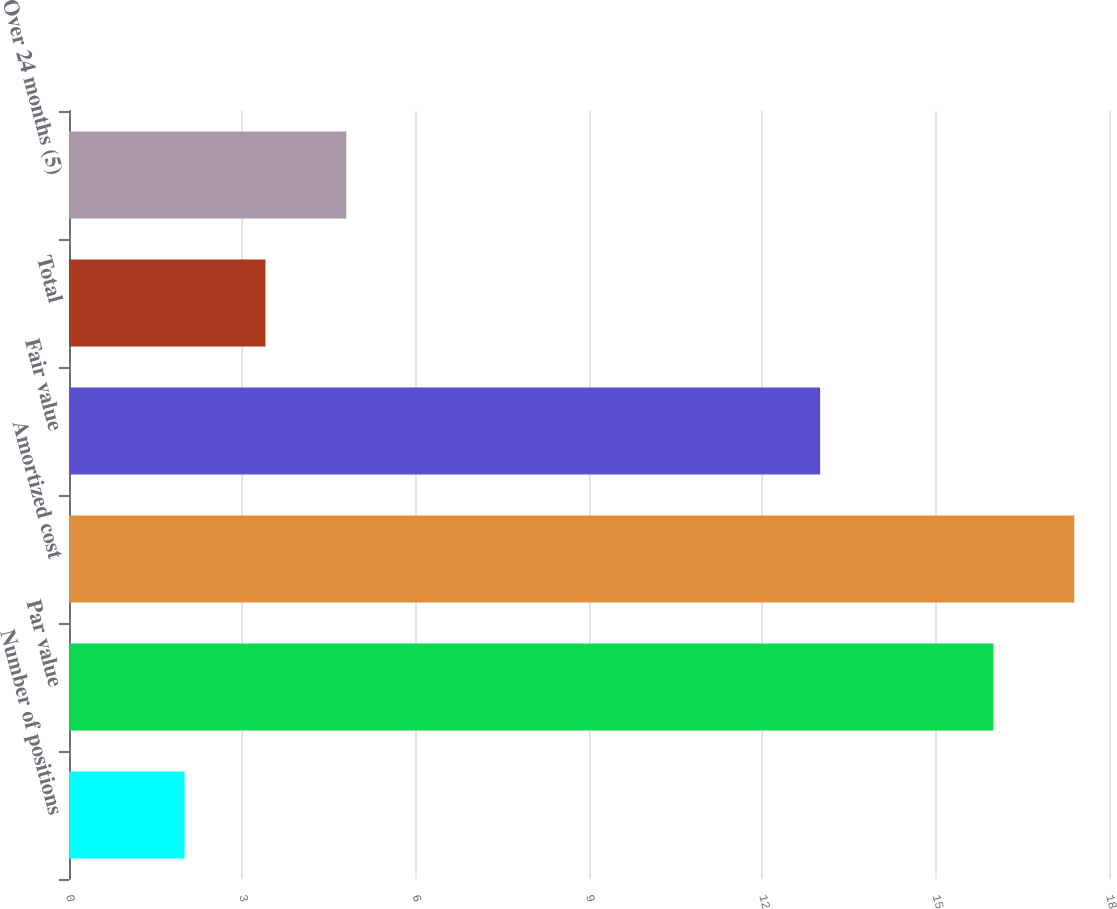Convert chart to OTSL. <chart><loc_0><loc_0><loc_500><loc_500><bar_chart><fcel>Number of positions<fcel>Par value<fcel>Amortized cost<fcel>Fair value<fcel>Total<fcel>Over 24 months (5)<nl><fcel>2<fcel>16<fcel>17.4<fcel>13<fcel>3.4<fcel>4.8<nl></chart> 